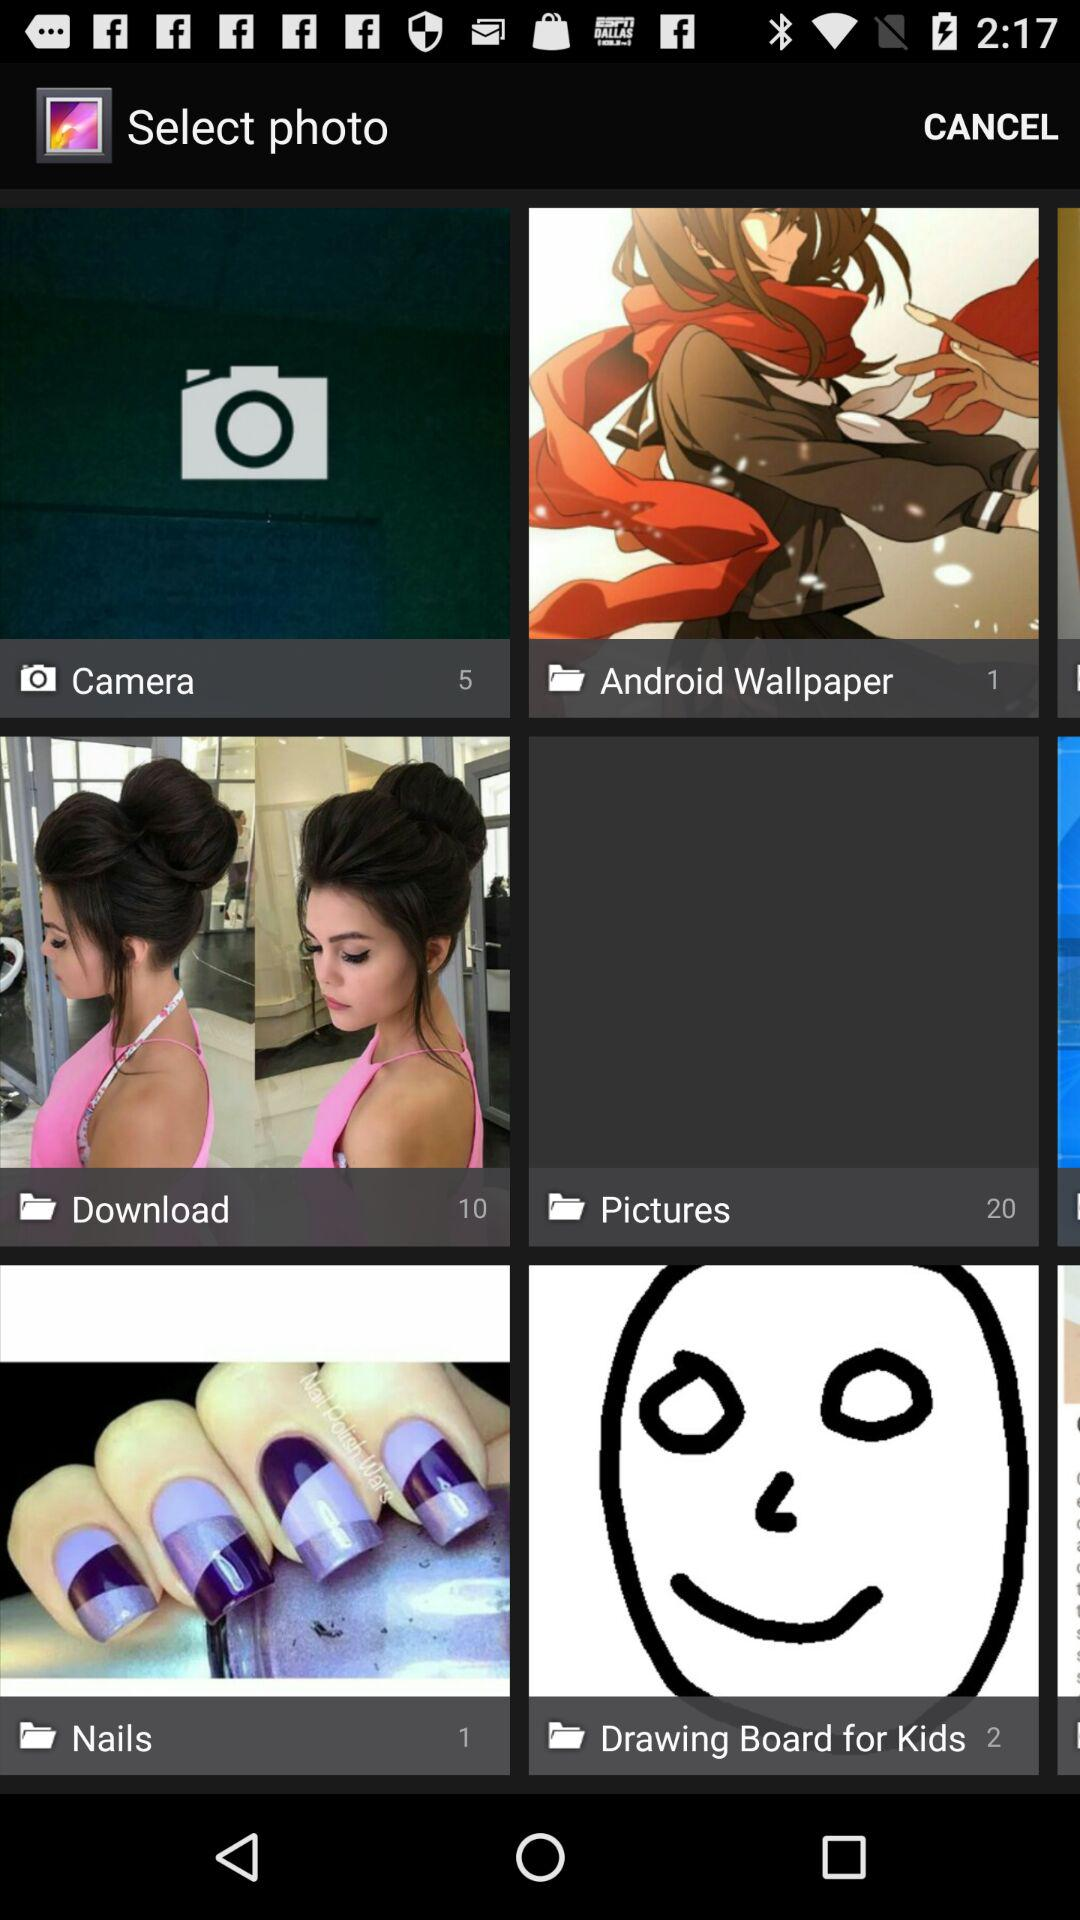How many images are there in the "Download" folder? There are 10 images in the "Download" folder. 